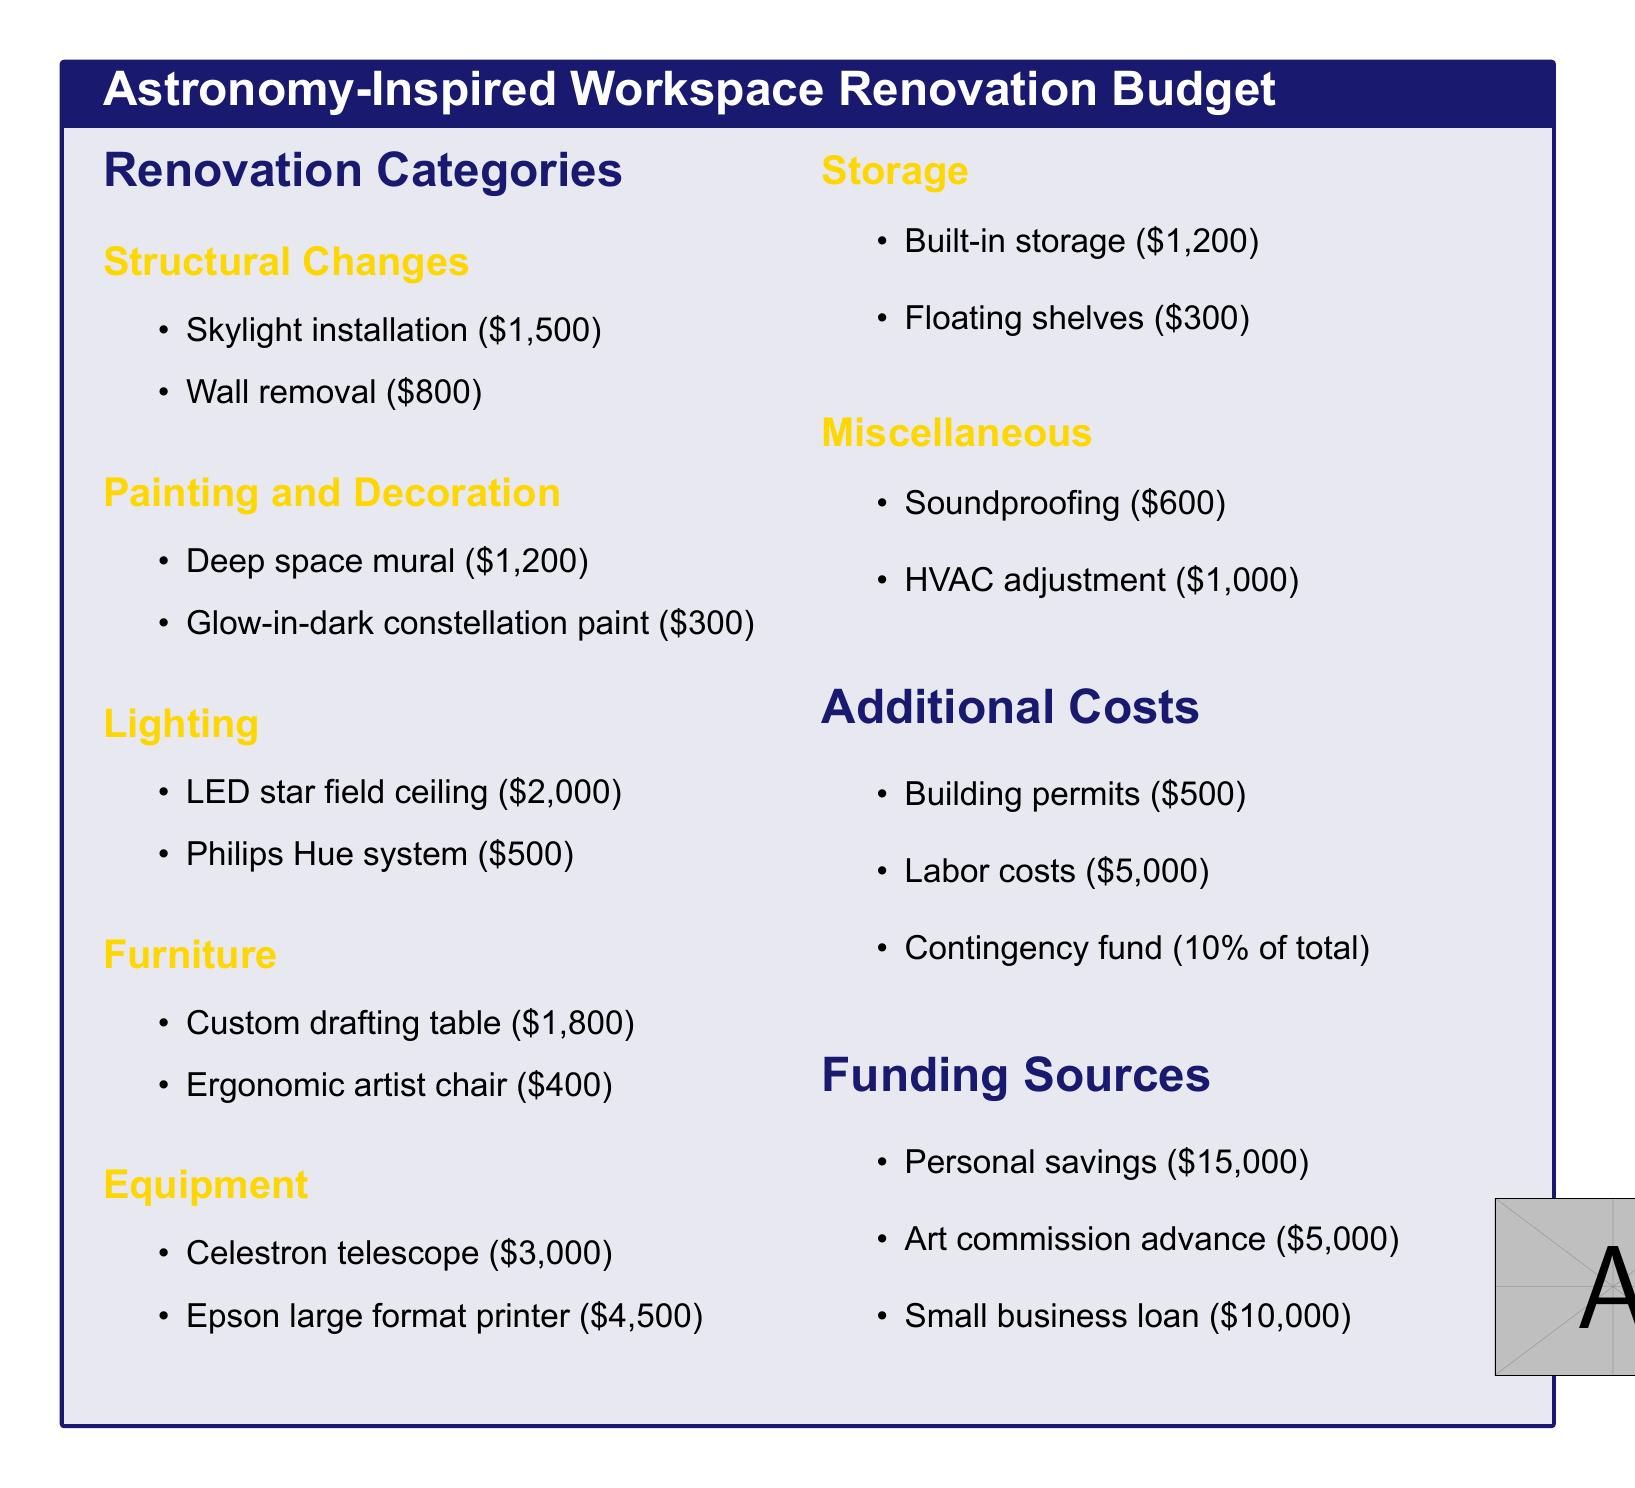What is the total cost of structural changes? The cost of structural changes includes the skylight installation and wall removal, totaling $1,500 + $800.
Answer: $2,300 How much is allocated for lighting? The budget for lighting includes an LED star field ceiling and a Philips Hue system, totaling $2,000 + $500.
Answer: $2,500 What is the cost of the Celestron telescope? The document lists the price of the Celestron telescope as $3,000.
Answer: $3,000 What is the amount in personal savings? The personal savings listed as a funding source is $15,000.
Answer: $15,000 How much is the contingency fund? The contingency fund is mentioned as 10% of the total costs calculated.
Answer: 10% of total costs 